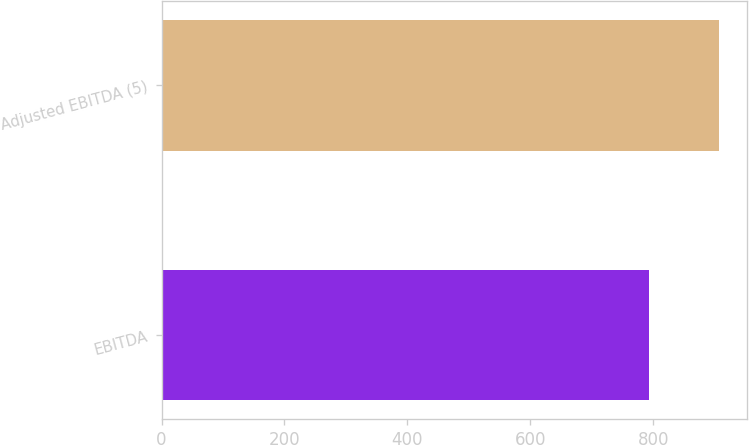Convert chart to OTSL. <chart><loc_0><loc_0><loc_500><loc_500><bar_chart><fcel>EBITDA<fcel>Adjusted EBITDA (5)<nl><fcel>792.9<fcel>907<nl></chart> 